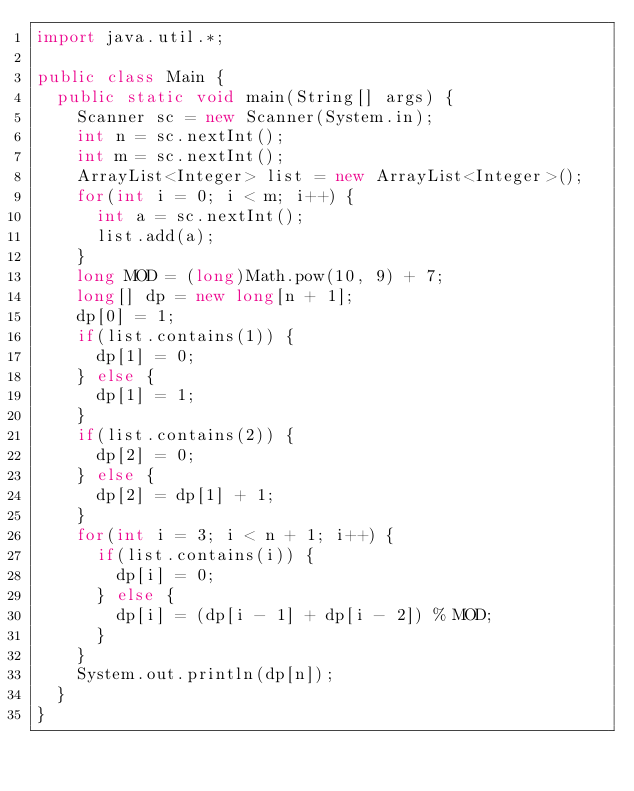Convert code to text. <code><loc_0><loc_0><loc_500><loc_500><_Java_>import java.util.*;

public class Main {
  public static void main(String[] args) {
    Scanner sc = new Scanner(System.in);
    int n = sc.nextInt();
    int m = sc.nextInt();
    ArrayList<Integer> list = new ArrayList<Integer>();
    for(int i = 0; i < m; i++) {
      int a = sc.nextInt();
      list.add(a);
    }
    long MOD = (long)Math.pow(10, 9) + 7;
    long[] dp = new long[n + 1];
    dp[0] = 1;
    if(list.contains(1)) {
      dp[1] = 0;
    } else {
      dp[1] = 1;
    }
    if(list.contains(2)) {
      dp[2] = 0;
    } else {
      dp[2] = dp[1] + 1;
    }
    for(int i = 3; i < n + 1; i++) {
      if(list.contains(i)) {
        dp[i] = 0;
      } else {
        dp[i] = (dp[i - 1] + dp[i - 2]) % MOD;
      }
    }
    System.out.println(dp[n]);
  }
}
</code> 